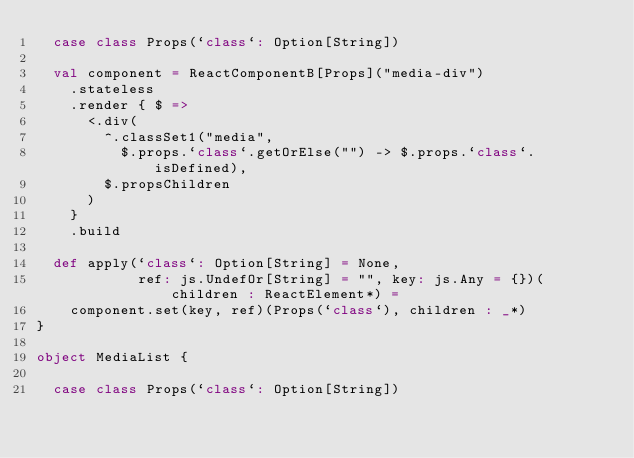Convert code to text. <code><loc_0><loc_0><loc_500><loc_500><_Scala_>  case class Props(`class`: Option[String])

  val component = ReactComponentB[Props]("media-div")
    .stateless
    .render { $ =>
      <.div(
        ^.classSet1("media",
          $.props.`class`.getOrElse("") -> $.props.`class`.isDefined),
        $.propsChildren
      )
    }
    .build

  def apply(`class`: Option[String] = None,
            ref: js.UndefOr[String] = "", key: js.Any = {})(children : ReactElement*) =
    component.set(key, ref)(Props(`class`), children : _*)
}

object MediaList {

  case class Props(`class`: Option[String])
</code> 